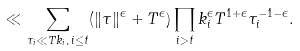Convert formula to latex. <formula><loc_0><loc_0><loc_500><loc_500>\ll \sum _ { \tau _ { i } \ll T k _ { i } , \, i \leq t } ( \| \tau \| ^ { \epsilon } + T ^ { \epsilon } ) \prod _ { i > t } k _ { i } ^ { \epsilon } T ^ { 1 + \epsilon } \tau _ { i } ^ { - 1 - \epsilon } .</formula> 